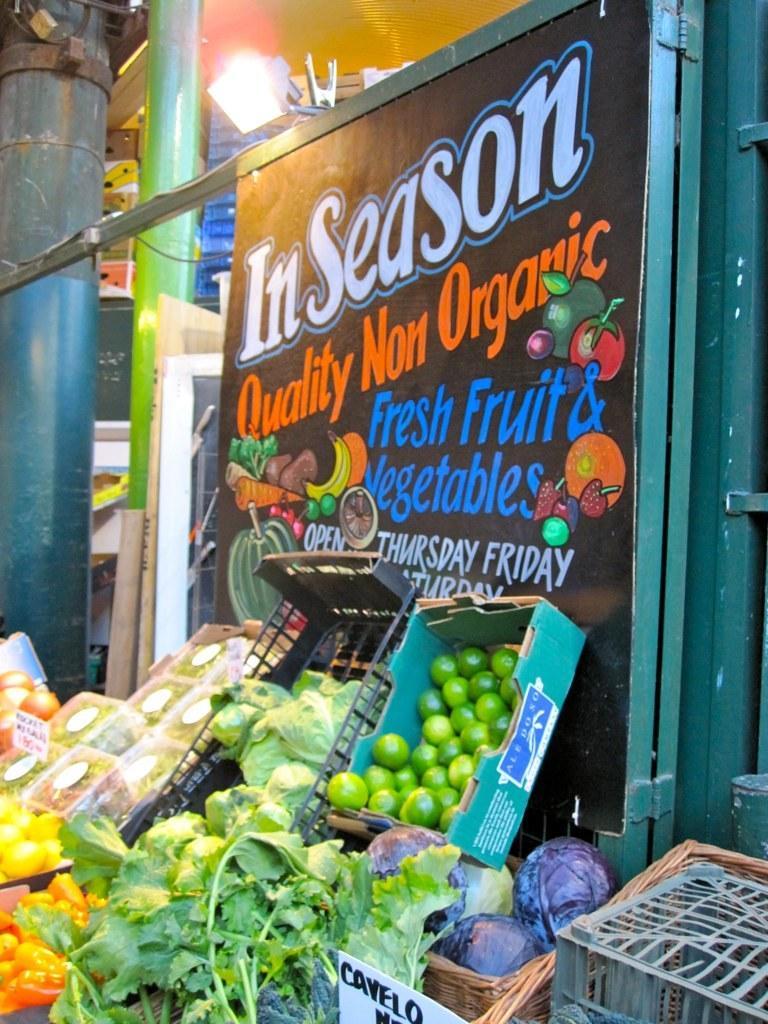Describe this image in one or two sentences. In this image there are boxes. In that box there are some fruits and leafy vegetables. And at the background there is a door, On the door there is a text written on paper and attached to it. At side there is a pillar and there are some objects. 